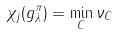<formula> <loc_0><loc_0><loc_500><loc_500>\chi _ { j } ( g _ { \lambda } ^ { \pi } ) = \min _ { C } \nu _ { C }</formula> 